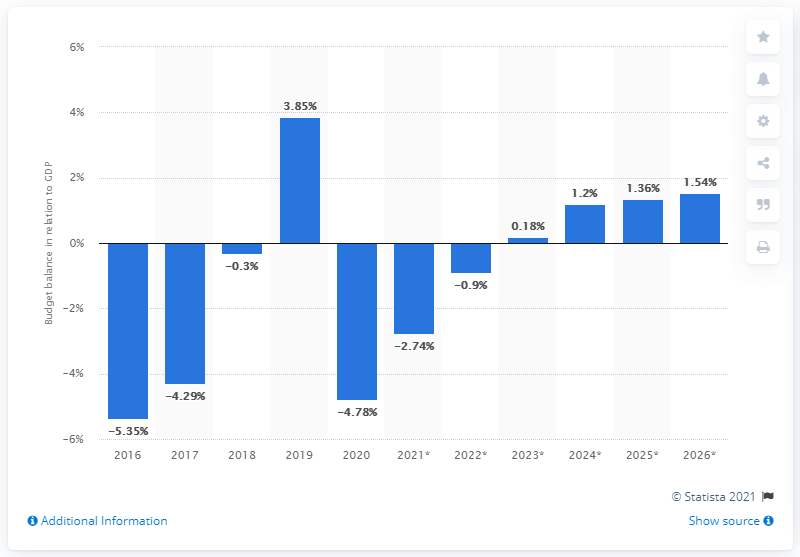Mention a couple of crucial points in this snapshot. Barbados' budget balance in relation to GDP will be in 2020. 